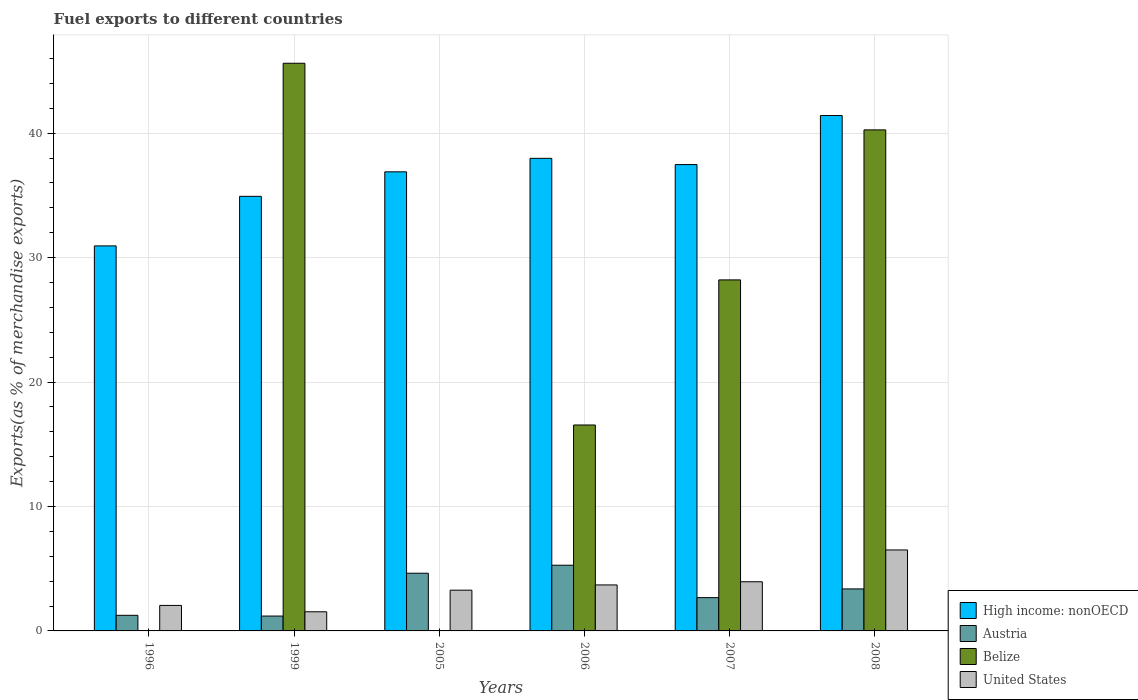How many bars are there on the 4th tick from the left?
Offer a terse response. 4. What is the label of the 3rd group of bars from the left?
Ensure brevity in your answer.  2005. What is the percentage of exports to different countries in Austria in 2007?
Provide a succinct answer. 2.67. Across all years, what is the maximum percentage of exports to different countries in United States?
Offer a very short reply. 6.51. Across all years, what is the minimum percentage of exports to different countries in Belize?
Provide a short and direct response. 9.66092252654547e-5. In which year was the percentage of exports to different countries in Belize minimum?
Ensure brevity in your answer.  2005. What is the total percentage of exports to different countries in Austria in the graph?
Offer a terse response. 18.41. What is the difference between the percentage of exports to different countries in High income: nonOECD in 1996 and that in 2006?
Make the answer very short. -7.04. What is the difference between the percentage of exports to different countries in High income: nonOECD in 2006 and the percentage of exports to different countries in Belize in 1999?
Offer a very short reply. -7.64. What is the average percentage of exports to different countries in Austria per year?
Ensure brevity in your answer.  3.07. In the year 2006, what is the difference between the percentage of exports to different countries in United States and percentage of exports to different countries in High income: nonOECD?
Keep it short and to the point. -34.28. In how many years, is the percentage of exports to different countries in United States greater than 24 %?
Make the answer very short. 0. What is the ratio of the percentage of exports to different countries in Austria in 1999 to that in 2007?
Offer a very short reply. 0.45. Is the percentage of exports to different countries in United States in 2005 less than that in 2006?
Give a very brief answer. Yes. Is the difference between the percentage of exports to different countries in United States in 1999 and 2005 greater than the difference between the percentage of exports to different countries in High income: nonOECD in 1999 and 2005?
Ensure brevity in your answer.  Yes. What is the difference between the highest and the second highest percentage of exports to different countries in United States?
Provide a short and direct response. 2.56. What is the difference between the highest and the lowest percentage of exports to different countries in United States?
Offer a terse response. 4.97. Is the sum of the percentage of exports to different countries in High income: nonOECD in 2005 and 2007 greater than the maximum percentage of exports to different countries in Austria across all years?
Keep it short and to the point. Yes. What does the 1st bar from the left in 2007 represents?
Provide a succinct answer. High income: nonOECD. Is it the case that in every year, the sum of the percentage of exports to different countries in Belize and percentage of exports to different countries in United States is greater than the percentage of exports to different countries in Austria?
Your answer should be compact. No. How many bars are there?
Provide a succinct answer. 24. How many years are there in the graph?
Provide a short and direct response. 6. What is the difference between two consecutive major ticks on the Y-axis?
Offer a very short reply. 10. Does the graph contain any zero values?
Offer a terse response. No. Does the graph contain grids?
Provide a succinct answer. Yes. How many legend labels are there?
Your answer should be compact. 4. What is the title of the graph?
Your answer should be very brief. Fuel exports to different countries. Does "France" appear as one of the legend labels in the graph?
Keep it short and to the point. No. What is the label or title of the Y-axis?
Offer a very short reply. Exports(as % of merchandise exports). What is the Exports(as % of merchandise exports) in High income: nonOECD in 1996?
Offer a very short reply. 30.94. What is the Exports(as % of merchandise exports) in Austria in 1996?
Your answer should be very brief. 1.25. What is the Exports(as % of merchandise exports) in Belize in 1996?
Give a very brief answer. 0. What is the Exports(as % of merchandise exports) of United States in 1996?
Provide a short and direct response. 2.05. What is the Exports(as % of merchandise exports) in High income: nonOECD in 1999?
Your answer should be very brief. 34.92. What is the Exports(as % of merchandise exports) in Austria in 1999?
Your response must be concise. 1.19. What is the Exports(as % of merchandise exports) of Belize in 1999?
Your response must be concise. 45.62. What is the Exports(as % of merchandise exports) of United States in 1999?
Offer a terse response. 1.54. What is the Exports(as % of merchandise exports) of High income: nonOECD in 2005?
Ensure brevity in your answer.  36.89. What is the Exports(as % of merchandise exports) in Austria in 2005?
Your response must be concise. 4.64. What is the Exports(as % of merchandise exports) in Belize in 2005?
Provide a succinct answer. 9.66092252654547e-5. What is the Exports(as % of merchandise exports) of United States in 2005?
Your answer should be compact. 3.27. What is the Exports(as % of merchandise exports) of High income: nonOECD in 2006?
Your answer should be compact. 37.98. What is the Exports(as % of merchandise exports) in Austria in 2006?
Your response must be concise. 5.28. What is the Exports(as % of merchandise exports) in Belize in 2006?
Keep it short and to the point. 16.55. What is the Exports(as % of merchandise exports) in United States in 2006?
Provide a succinct answer. 3.7. What is the Exports(as % of merchandise exports) in High income: nonOECD in 2007?
Your answer should be very brief. 37.48. What is the Exports(as % of merchandise exports) in Austria in 2007?
Your answer should be compact. 2.67. What is the Exports(as % of merchandise exports) of Belize in 2007?
Offer a terse response. 28.21. What is the Exports(as % of merchandise exports) of United States in 2007?
Offer a very short reply. 3.95. What is the Exports(as % of merchandise exports) of High income: nonOECD in 2008?
Offer a very short reply. 41.42. What is the Exports(as % of merchandise exports) of Austria in 2008?
Offer a very short reply. 3.38. What is the Exports(as % of merchandise exports) of Belize in 2008?
Offer a terse response. 40.26. What is the Exports(as % of merchandise exports) in United States in 2008?
Keep it short and to the point. 6.51. Across all years, what is the maximum Exports(as % of merchandise exports) of High income: nonOECD?
Provide a short and direct response. 41.42. Across all years, what is the maximum Exports(as % of merchandise exports) of Austria?
Give a very brief answer. 5.28. Across all years, what is the maximum Exports(as % of merchandise exports) in Belize?
Provide a short and direct response. 45.62. Across all years, what is the maximum Exports(as % of merchandise exports) in United States?
Your answer should be very brief. 6.51. Across all years, what is the minimum Exports(as % of merchandise exports) of High income: nonOECD?
Make the answer very short. 30.94. Across all years, what is the minimum Exports(as % of merchandise exports) in Austria?
Keep it short and to the point. 1.19. Across all years, what is the minimum Exports(as % of merchandise exports) of Belize?
Offer a very short reply. 9.66092252654547e-5. Across all years, what is the minimum Exports(as % of merchandise exports) of United States?
Offer a terse response. 1.54. What is the total Exports(as % of merchandise exports) in High income: nonOECD in the graph?
Ensure brevity in your answer.  219.62. What is the total Exports(as % of merchandise exports) in Austria in the graph?
Your answer should be very brief. 18.41. What is the total Exports(as % of merchandise exports) of Belize in the graph?
Offer a terse response. 130.64. What is the total Exports(as % of merchandise exports) in United States in the graph?
Offer a very short reply. 21.01. What is the difference between the Exports(as % of merchandise exports) of High income: nonOECD in 1996 and that in 1999?
Offer a very short reply. -3.98. What is the difference between the Exports(as % of merchandise exports) in Austria in 1996 and that in 1999?
Your answer should be very brief. 0.06. What is the difference between the Exports(as % of merchandise exports) in Belize in 1996 and that in 1999?
Your answer should be very brief. -45.62. What is the difference between the Exports(as % of merchandise exports) in United States in 1996 and that in 1999?
Provide a succinct answer. 0.51. What is the difference between the Exports(as % of merchandise exports) in High income: nonOECD in 1996 and that in 2005?
Provide a short and direct response. -5.95. What is the difference between the Exports(as % of merchandise exports) in Austria in 1996 and that in 2005?
Provide a short and direct response. -3.38. What is the difference between the Exports(as % of merchandise exports) in United States in 1996 and that in 2005?
Make the answer very short. -1.23. What is the difference between the Exports(as % of merchandise exports) of High income: nonOECD in 1996 and that in 2006?
Keep it short and to the point. -7.04. What is the difference between the Exports(as % of merchandise exports) in Austria in 1996 and that in 2006?
Give a very brief answer. -4.02. What is the difference between the Exports(as % of merchandise exports) in Belize in 1996 and that in 2006?
Offer a very short reply. -16.55. What is the difference between the Exports(as % of merchandise exports) of United States in 1996 and that in 2006?
Give a very brief answer. -1.65. What is the difference between the Exports(as % of merchandise exports) in High income: nonOECD in 1996 and that in 2007?
Offer a very short reply. -6.54. What is the difference between the Exports(as % of merchandise exports) of Austria in 1996 and that in 2007?
Give a very brief answer. -1.42. What is the difference between the Exports(as % of merchandise exports) of Belize in 1996 and that in 2007?
Give a very brief answer. -28.21. What is the difference between the Exports(as % of merchandise exports) of United States in 1996 and that in 2007?
Your answer should be very brief. -1.9. What is the difference between the Exports(as % of merchandise exports) in High income: nonOECD in 1996 and that in 2008?
Provide a succinct answer. -10.48. What is the difference between the Exports(as % of merchandise exports) in Austria in 1996 and that in 2008?
Offer a very short reply. -2.12. What is the difference between the Exports(as % of merchandise exports) of Belize in 1996 and that in 2008?
Make the answer very short. -40.26. What is the difference between the Exports(as % of merchandise exports) of United States in 1996 and that in 2008?
Keep it short and to the point. -4.46. What is the difference between the Exports(as % of merchandise exports) in High income: nonOECD in 1999 and that in 2005?
Provide a short and direct response. -1.97. What is the difference between the Exports(as % of merchandise exports) of Austria in 1999 and that in 2005?
Your answer should be compact. -3.44. What is the difference between the Exports(as % of merchandise exports) of Belize in 1999 and that in 2005?
Your response must be concise. 45.62. What is the difference between the Exports(as % of merchandise exports) in United States in 1999 and that in 2005?
Your answer should be very brief. -1.74. What is the difference between the Exports(as % of merchandise exports) in High income: nonOECD in 1999 and that in 2006?
Ensure brevity in your answer.  -3.05. What is the difference between the Exports(as % of merchandise exports) in Austria in 1999 and that in 2006?
Keep it short and to the point. -4.08. What is the difference between the Exports(as % of merchandise exports) of Belize in 1999 and that in 2006?
Your answer should be very brief. 29.07. What is the difference between the Exports(as % of merchandise exports) of United States in 1999 and that in 2006?
Your response must be concise. -2.16. What is the difference between the Exports(as % of merchandise exports) in High income: nonOECD in 1999 and that in 2007?
Give a very brief answer. -2.55. What is the difference between the Exports(as % of merchandise exports) in Austria in 1999 and that in 2007?
Give a very brief answer. -1.48. What is the difference between the Exports(as % of merchandise exports) of Belize in 1999 and that in 2007?
Make the answer very short. 17.41. What is the difference between the Exports(as % of merchandise exports) in United States in 1999 and that in 2007?
Give a very brief answer. -2.41. What is the difference between the Exports(as % of merchandise exports) in High income: nonOECD in 1999 and that in 2008?
Offer a terse response. -6.49. What is the difference between the Exports(as % of merchandise exports) in Austria in 1999 and that in 2008?
Provide a short and direct response. -2.18. What is the difference between the Exports(as % of merchandise exports) of Belize in 1999 and that in 2008?
Provide a succinct answer. 5.35. What is the difference between the Exports(as % of merchandise exports) in United States in 1999 and that in 2008?
Give a very brief answer. -4.97. What is the difference between the Exports(as % of merchandise exports) in High income: nonOECD in 2005 and that in 2006?
Provide a short and direct response. -1.08. What is the difference between the Exports(as % of merchandise exports) of Austria in 2005 and that in 2006?
Your response must be concise. -0.64. What is the difference between the Exports(as % of merchandise exports) of Belize in 2005 and that in 2006?
Offer a terse response. -16.55. What is the difference between the Exports(as % of merchandise exports) of United States in 2005 and that in 2006?
Your answer should be very brief. -0.42. What is the difference between the Exports(as % of merchandise exports) in High income: nonOECD in 2005 and that in 2007?
Keep it short and to the point. -0.58. What is the difference between the Exports(as % of merchandise exports) in Austria in 2005 and that in 2007?
Ensure brevity in your answer.  1.96. What is the difference between the Exports(as % of merchandise exports) of Belize in 2005 and that in 2007?
Offer a very short reply. -28.21. What is the difference between the Exports(as % of merchandise exports) in United States in 2005 and that in 2007?
Your answer should be compact. -0.68. What is the difference between the Exports(as % of merchandise exports) of High income: nonOECD in 2005 and that in 2008?
Ensure brevity in your answer.  -4.52. What is the difference between the Exports(as % of merchandise exports) in Austria in 2005 and that in 2008?
Your response must be concise. 1.26. What is the difference between the Exports(as % of merchandise exports) in Belize in 2005 and that in 2008?
Your answer should be very brief. -40.26. What is the difference between the Exports(as % of merchandise exports) in United States in 2005 and that in 2008?
Offer a terse response. -3.23. What is the difference between the Exports(as % of merchandise exports) of High income: nonOECD in 2006 and that in 2007?
Provide a short and direct response. 0.5. What is the difference between the Exports(as % of merchandise exports) of Austria in 2006 and that in 2007?
Provide a short and direct response. 2.6. What is the difference between the Exports(as % of merchandise exports) of Belize in 2006 and that in 2007?
Keep it short and to the point. -11.66. What is the difference between the Exports(as % of merchandise exports) of United States in 2006 and that in 2007?
Offer a very short reply. -0.26. What is the difference between the Exports(as % of merchandise exports) in High income: nonOECD in 2006 and that in 2008?
Offer a terse response. -3.44. What is the difference between the Exports(as % of merchandise exports) in Austria in 2006 and that in 2008?
Provide a short and direct response. 1.9. What is the difference between the Exports(as % of merchandise exports) of Belize in 2006 and that in 2008?
Offer a very short reply. -23.71. What is the difference between the Exports(as % of merchandise exports) of United States in 2006 and that in 2008?
Offer a very short reply. -2.81. What is the difference between the Exports(as % of merchandise exports) of High income: nonOECD in 2007 and that in 2008?
Your answer should be compact. -3.94. What is the difference between the Exports(as % of merchandise exports) in Austria in 2007 and that in 2008?
Give a very brief answer. -0.7. What is the difference between the Exports(as % of merchandise exports) of Belize in 2007 and that in 2008?
Keep it short and to the point. -12.05. What is the difference between the Exports(as % of merchandise exports) of United States in 2007 and that in 2008?
Your answer should be compact. -2.56. What is the difference between the Exports(as % of merchandise exports) in High income: nonOECD in 1996 and the Exports(as % of merchandise exports) in Austria in 1999?
Offer a terse response. 29.75. What is the difference between the Exports(as % of merchandise exports) of High income: nonOECD in 1996 and the Exports(as % of merchandise exports) of Belize in 1999?
Your answer should be very brief. -14.68. What is the difference between the Exports(as % of merchandise exports) of High income: nonOECD in 1996 and the Exports(as % of merchandise exports) of United States in 1999?
Keep it short and to the point. 29.4. What is the difference between the Exports(as % of merchandise exports) in Austria in 1996 and the Exports(as % of merchandise exports) in Belize in 1999?
Provide a succinct answer. -44.36. What is the difference between the Exports(as % of merchandise exports) in Austria in 1996 and the Exports(as % of merchandise exports) in United States in 1999?
Make the answer very short. -0.28. What is the difference between the Exports(as % of merchandise exports) of Belize in 1996 and the Exports(as % of merchandise exports) of United States in 1999?
Give a very brief answer. -1.54. What is the difference between the Exports(as % of merchandise exports) in High income: nonOECD in 1996 and the Exports(as % of merchandise exports) in Austria in 2005?
Offer a terse response. 26.3. What is the difference between the Exports(as % of merchandise exports) in High income: nonOECD in 1996 and the Exports(as % of merchandise exports) in Belize in 2005?
Offer a very short reply. 30.94. What is the difference between the Exports(as % of merchandise exports) in High income: nonOECD in 1996 and the Exports(as % of merchandise exports) in United States in 2005?
Provide a succinct answer. 27.67. What is the difference between the Exports(as % of merchandise exports) in Austria in 1996 and the Exports(as % of merchandise exports) in Belize in 2005?
Offer a very short reply. 1.25. What is the difference between the Exports(as % of merchandise exports) in Austria in 1996 and the Exports(as % of merchandise exports) in United States in 2005?
Provide a short and direct response. -2.02. What is the difference between the Exports(as % of merchandise exports) of Belize in 1996 and the Exports(as % of merchandise exports) of United States in 2005?
Your response must be concise. -3.27. What is the difference between the Exports(as % of merchandise exports) in High income: nonOECD in 1996 and the Exports(as % of merchandise exports) in Austria in 2006?
Give a very brief answer. 25.66. What is the difference between the Exports(as % of merchandise exports) of High income: nonOECD in 1996 and the Exports(as % of merchandise exports) of Belize in 2006?
Give a very brief answer. 14.39. What is the difference between the Exports(as % of merchandise exports) in High income: nonOECD in 1996 and the Exports(as % of merchandise exports) in United States in 2006?
Provide a short and direct response. 27.24. What is the difference between the Exports(as % of merchandise exports) in Austria in 1996 and the Exports(as % of merchandise exports) in Belize in 2006?
Provide a succinct answer. -15.29. What is the difference between the Exports(as % of merchandise exports) of Austria in 1996 and the Exports(as % of merchandise exports) of United States in 2006?
Keep it short and to the point. -2.44. What is the difference between the Exports(as % of merchandise exports) in Belize in 1996 and the Exports(as % of merchandise exports) in United States in 2006?
Ensure brevity in your answer.  -3.7. What is the difference between the Exports(as % of merchandise exports) of High income: nonOECD in 1996 and the Exports(as % of merchandise exports) of Austria in 2007?
Make the answer very short. 28.27. What is the difference between the Exports(as % of merchandise exports) of High income: nonOECD in 1996 and the Exports(as % of merchandise exports) of Belize in 2007?
Offer a terse response. 2.73. What is the difference between the Exports(as % of merchandise exports) in High income: nonOECD in 1996 and the Exports(as % of merchandise exports) in United States in 2007?
Ensure brevity in your answer.  26.99. What is the difference between the Exports(as % of merchandise exports) of Austria in 1996 and the Exports(as % of merchandise exports) of Belize in 2007?
Offer a very short reply. -26.95. What is the difference between the Exports(as % of merchandise exports) of Austria in 1996 and the Exports(as % of merchandise exports) of United States in 2007?
Ensure brevity in your answer.  -2.7. What is the difference between the Exports(as % of merchandise exports) in Belize in 1996 and the Exports(as % of merchandise exports) in United States in 2007?
Provide a succinct answer. -3.95. What is the difference between the Exports(as % of merchandise exports) in High income: nonOECD in 1996 and the Exports(as % of merchandise exports) in Austria in 2008?
Keep it short and to the point. 27.56. What is the difference between the Exports(as % of merchandise exports) in High income: nonOECD in 1996 and the Exports(as % of merchandise exports) in Belize in 2008?
Give a very brief answer. -9.32. What is the difference between the Exports(as % of merchandise exports) of High income: nonOECD in 1996 and the Exports(as % of merchandise exports) of United States in 2008?
Provide a short and direct response. 24.43. What is the difference between the Exports(as % of merchandise exports) of Austria in 1996 and the Exports(as % of merchandise exports) of Belize in 2008?
Provide a short and direct response. -39.01. What is the difference between the Exports(as % of merchandise exports) of Austria in 1996 and the Exports(as % of merchandise exports) of United States in 2008?
Keep it short and to the point. -5.25. What is the difference between the Exports(as % of merchandise exports) of Belize in 1996 and the Exports(as % of merchandise exports) of United States in 2008?
Offer a terse response. -6.51. What is the difference between the Exports(as % of merchandise exports) of High income: nonOECD in 1999 and the Exports(as % of merchandise exports) of Austria in 2005?
Ensure brevity in your answer.  30.29. What is the difference between the Exports(as % of merchandise exports) of High income: nonOECD in 1999 and the Exports(as % of merchandise exports) of Belize in 2005?
Your response must be concise. 34.92. What is the difference between the Exports(as % of merchandise exports) in High income: nonOECD in 1999 and the Exports(as % of merchandise exports) in United States in 2005?
Provide a succinct answer. 31.65. What is the difference between the Exports(as % of merchandise exports) in Austria in 1999 and the Exports(as % of merchandise exports) in Belize in 2005?
Ensure brevity in your answer.  1.19. What is the difference between the Exports(as % of merchandise exports) of Austria in 1999 and the Exports(as % of merchandise exports) of United States in 2005?
Your answer should be very brief. -2.08. What is the difference between the Exports(as % of merchandise exports) in Belize in 1999 and the Exports(as % of merchandise exports) in United States in 2005?
Provide a succinct answer. 42.34. What is the difference between the Exports(as % of merchandise exports) of High income: nonOECD in 1999 and the Exports(as % of merchandise exports) of Austria in 2006?
Make the answer very short. 29.64. What is the difference between the Exports(as % of merchandise exports) of High income: nonOECD in 1999 and the Exports(as % of merchandise exports) of Belize in 2006?
Give a very brief answer. 18.38. What is the difference between the Exports(as % of merchandise exports) of High income: nonOECD in 1999 and the Exports(as % of merchandise exports) of United States in 2006?
Give a very brief answer. 31.23. What is the difference between the Exports(as % of merchandise exports) in Austria in 1999 and the Exports(as % of merchandise exports) in Belize in 2006?
Ensure brevity in your answer.  -15.35. What is the difference between the Exports(as % of merchandise exports) of Austria in 1999 and the Exports(as % of merchandise exports) of United States in 2006?
Your response must be concise. -2.5. What is the difference between the Exports(as % of merchandise exports) in Belize in 1999 and the Exports(as % of merchandise exports) in United States in 2006?
Make the answer very short. 41.92. What is the difference between the Exports(as % of merchandise exports) of High income: nonOECD in 1999 and the Exports(as % of merchandise exports) of Austria in 2007?
Offer a terse response. 32.25. What is the difference between the Exports(as % of merchandise exports) of High income: nonOECD in 1999 and the Exports(as % of merchandise exports) of Belize in 2007?
Make the answer very short. 6.72. What is the difference between the Exports(as % of merchandise exports) of High income: nonOECD in 1999 and the Exports(as % of merchandise exports) of United States in 2007?
Your answer should be very brief. 30.97. What is the difference between the Exports(as % of merchandise exports) in Austria in 1999 and the Exports(as % of merchandise exports) in Belize in 2007?
Offer a terse response. -27.01. What is the difference between the Exports(as % of merchandise exports) of Austria in 1999 and the Exports(as % of merchandise exports) of United States in 2007?
Your answer should be very brief. -2.76. What is the difference between the Exports(as % of merchandise exports) in Belize in 1999 and the Exports(as % of merchandise exports) in United States in 2007?
Your answer should be compact. 41.67. What is the difference between the Exports(as % of merchandise exports) in High income: nonOECD in 1999 and the Exports(as % of merchandise exports) in Austria in 2008?
Offer a very short reply. 31.55. What is the difference between the Exports(as % of merchandise exports) of High income: nonOECD in 1999 and the Exports(as % of merchandise exports) of Belize in 2008?
Ensure brevity in your answer.  -5.34. What is the difference between the Exports(as % of merchandise exports) in High income: nonOECD in 1999 and the Exports(as % of merchandise exports) in United States in 2008?
Your response must be concise. 28.42. What is the difference between the Exports(as % of merchandise exports) in Austria in 1999 and the Exports(as % of merchandise exports) in Belize in 2008?
Offer a very short reply. -39.07. What is the difference between the Exports(as % of merchandise exports) in Austria in 1999 and the Exports(as % of merchandise exports) in United States in 2008?
Your response must be concise. -5.31. What is the difference between the Exports(as % of merchandise exports) in Belize in 1999 and the Exports(as % of merchandise exports) in United States in 2008?
Offer a very short reply. 39.11. What is the difference between the Exports(as % of merchandise exports) in High income: nonOECD in 2005 and the Exports(as % of merchandise exports) in Austria in 2006?
Provide a short and direct response. 31.61. What is the difference between the Exports(as % of merchandise exports) in High income: nonOECD in 2005 and the Exports(as % of merchandise exports) in Belize in 2006?
Offer a terse response. 20.34. What is the difference between the Exports(as % of merchandise exports) of High income: nonOECD in 2005 and the Exports(as % of merchandise exports) of United States in 2006?
Give a very brief answer. 33.2. What is the difference between the Exports(as % of merchandise exports) in Austria in 2005 and the Exports(as % of merchandise exports) in Belize in 2006?
Provide a succinct answer. -11.91. What is the difference between the Exports(as % of merchandise exports) in Austria in 2005 and the Exports(as % of merchandise exports) in United States in 2006?
Ensure brevity in your answer.  0.94. What is the difference between the Exports(as % of merchandise exports) of Belize in 2005 and the Exports(as % of merchandise exports) of United States in 2006?
Keep it short and to the point. -3.7. What is the difference between the Exports(as % of merchandise exports) in High income: nonOECD in 2005 and the Exports(as % of merchandise exports) in Austria in 2007?
Give a very brief answer. 34.22. What is the difference between the Exports(as % of merchandise exports) in High income: nonOECD in 2005 and the Exports(as % of merchandise exports) in Belize in 2007?
Make the answer very short. 8.68. What is the difference between the Exports(as % of merchandise exports) of High income: nonOECD in 2005 and the Exports(as % of merchandise exports) of United States in 2007?
Provide a short and direct response. 32.94. What is the difference between the Exports(as % of merchandise exports) in Austria in 2005 and the Exports(as % of merchandise exports) in Belize in 2007?
Your answer should be compact. -23.57. What is the difference between the Exports(as % of merchandise exports) of Austria in 2005 and the Exports(as % of merchandise exports) of United States in 2007?
Ensure brevity in your answer.  0.69. What is the difference between the Exports(as % of merchandise exports) of Belize in 2005 and the Exports(as % of merchandise exports) of United States in 2007?
Provide a succinct answer. -3.95. What is the difference between the Exports(as % of merchandise exports) of High income: nonOECD in 2005 and the Exports(as % of merchandise exports) of Austria in 2008?
Give a very brief answer. 33.52. What is the difference between the Exports(as % of merchandise exports) of High income: nonOECD in 2005 and the Exports(as % of merchandise exports) of Belize in 2008?
Give a very brief answer. -3.37. What is the difference between the Exports(as % of merchandise exports) in High income: nonOECD in 2005 and the Exports(as % of merchandise exports) in United States in 2008?
Offer a very short reply. 30.39. What is the difference between the Exports(as % of merchandise exports) of Austria in 2005 and the Exports(as % of merchandise exports) of Belize in 2008?
Keep it short and to the point. -35.63. What is the difference between the Exports(as % of merchandise exports) in Austria in 2005 and the Exports(as % of merchandise exports) in United States in 2008?
Ensure brevity in your answer.  -1.87. What is the difference between the Exports(as % of merchandise exports) in Belize in 2005 and the Exports(as % of merchandise exports) in United States in 2008?
Keep it short and to the point. -6.51. What is the difference between the Exports(as % of merchandise exports) of High income: nonOECD in 2006 and the Exports(as % of merchandise exports) of Austria in 2007?
Your answer should be very brief. 35.3. What is the difference between the Exports(as % of merchandise exports) of High income: nonOECD in 2006 and the Exports(as % of merchandise exports) of Belize in 2007?
Offer a terse response. 9.77. What is the difference between the Exports(as % of merchandise exports) in High income: nonOECD in 2006 and the Exports(as % of merchandise exports) in United States in 2007?
Ensure brevity in your answer.  34.02. What is the difference between the Exports(as % of merchandise exports) in Austria in 2006 and the Exports(as % of merchandise exports) in Belize in 2007?
Your answer should be compact. -22.93. What is the difference between the Exports(as % of merchandise exports) in Austria in 2006 and the Exports(as % of merchandise exports) in United States in 2007?
Your answer should be very brief. 1.33. What is the difference between the Exports(as % of merchandise exports) in Belize in 2006 and the Exports(as % of merchandise exports) in United States in 2007?
Provide a succinct answer. 12.6. What is the difference between the Exports(as % of merchandise exports) in High income: nonOECD in 2006 and the Exports(as % of merchandise exports) in Austria in 2008?
Give a very brief answer. 34.6. What is the difference between the Exports(as % of merchandise exports) in High income: nonOECD in 2006 and the Exports(as % of merchandise exports) in Belize in 2008?
Keep it short and to the point. -2.29. What is the difference between the Exports(as % of merchandise exports) in High income: nonOECD in 2006 and the Exports(as % of merchandise exports) in United States in 2008?
Your answer should be compact. 31.47. What is the difference between the Exports(as % of merchandise exports) in Austria in 2006 and the Exports(as % of merchandise exports) in Belize in 2008?
Your response must be concise. -34.98. What is the difference between the Exports(as % of merchandise exports) in Austria in 2006 and the Exports(as % of merchandise exports) in United States in 2008?
Keep it short and to the point. -1.23. What is the difference between the Exports(as % of merchandise exports) of Belize in 2006 and the Exports(as % of merchandise exports) of United States in 2008?
Keep it short and to the point. 10.04. What is the difference between the Exports(as % of merchandise exports) in High income: nonOECD in 2007 and the Exports(as % of merchandise exports) in Austria in 2008?
Ensure brevity in your answer.  34.1. What is the difference between the Exports(as % of merchandise exports) in High income: nonOECD in 2007 and the Exports(as % of merchandise exports) in Belize in 2008?
Provide a short and direct response. -2.79. What is the difference between the Exports(as % of merchandise exports) in High income: nonOECD in 2007 and the Exports(as % of merchandise exports) in United States in 2008?
Provide a succinct answer. 30.97. What is the difference between the Exports(as % of merchandise exports) in Austria in 2007 and the Exports(as % of merchandise exports) in Belize in 2008?
Offer a very short reply. -37.59. What is the difference between the Exports(as % of merchandise exports) of Austria in 2007 and the Exports(as % of merchandise exports) of United States in 2008?
Ensure brevity in your answer.  -3.83. What is the difference between the Exports(as % of merchandise exports) in Belize in 2007 and the Exports(as % of merchandise exports) in United States in 2008?
Your answer should be very brief. 21.7. What is the average Exports(as % of merchandise exports) in High income: nonOECD per year?
Your answer should be very brief. 36.6. What is the average Exports(as % of merchandise exports) of Austria per year?
Your response must be concise. 3.07. What is the average Exports(as % of merchandise exports) of Belize per year?
Provide a short and direct response. 21.77. What is the average Exports(as % of merchandise exports) in United States per year?
Offer a terse response. 3.5. In the year 1996, what is the difference between the Exports(as % of merchandise exports) in High income: nonOECD and Exports(as % of merchandise exports) in Austria?
Your answer should be very brief. 29.69. In the year 1996, what is the difference between the Exports(as % of merchandise exports) of High income: nonOECD and Exports(as % of merchandise exports) of Belize?
Offer a terse response. 30.94. In the year 1996, what is the difference between the Exports(as % of merchandise exports) in High income: nonOECD and Exports(as % of merchandise exports) in United States?
Keep it short and to the point. 28.89. In the year 1996, what is the difference between the Exports(as % of merchandise exports) in Austria and Exports(as % of merchandise exports) in Belize?
Offer a very short reply. 1.25. In the year 1996, what is the difference between the Exports(as % of merchandise exports) in Austria and Exports(as % of merchandise exports) in United States?
Your answer should be very brief. -0.79. In the year 1996, what is the difference between the Exports(as % of merchandise exports) in Belize and Exports(as % of merchandise exports) in United States?
Make the answer very short. -2.05. In the year 1999, what is the difference between the Exports(as % of merchandise exports) in High income: nonOECD and Exports(as % of merchandise exports) in Austria?
Provide a short and direct response. 33.73. In the year 1999, what is the difference between the Exports(as % of merchandise exports) of High income: nonOECD and Exports(as % of merchandise exports) of Belize?
Your response must be concise. -10.69. In the year 1999, what is the difference between the Exports(as % of merchandise exports) in High income: nonOECD and Exports(as % of merchandise exports) in United States?
Offer a terse response. 33.38. In the year 1999, what is the difference between the Exports(as % of merchandise exports) in Austria and Exports(as % of merchandise exports) in Belize?
Offer a terse response. -44.42. In the year 1999, what is the difference between the Exports(as % of merchandise exports) of Austria and Exports(as % of merchandise exports) of United States?
Keep it short and to the point. -0.34. In the year 1999, what is the difference between the Exports(as % of merchandise exports) of Belize and Exports(as % of merchandise exports) of United States?
Offer a terse response. 44.08. In the year 2005, what is the difference between the Exports(as % of merchandise exports) of High income: nonOECD and Exports(as % of merchandise exports) of Austria?
Offer a terse response. 32.26. In the year 2005, what is the difference between the Exports(as % of merchandise exports) in High income: nonOECD and Exports(as % of merchandise exports) in Belize?
Your response must be concise. 36.89. In the year 2005, what is the difference between the Exports(as % of merchandise exports) of High income: nonOECD and Exports(as % of merchandise exports) of United States?
Provide a short and direct response. 33.62. In the year 2005, what is the difference between the Exports(as % of merchandise exports) of Austria and Exports(as % of merchandise exports) of Belize?
Provide a succinct answer. 4.64. In the year 2005, what is the difference between the Exports(as % of merchandise exports) in Austria and Exports(as % of merchandise exports) in United States?
Offer a terse response. 1.36. In the year 2005, what is the difference between the Exports(as % of merchandise exports) in Belize and Exports(as % of merchandise exports) in United States?
Provide a succinct answer. -3.27. In the year 2006, what is the difference between the Exports(as % of merchandise exports) in High income: nonOECD and Exports(as % of merchandise exports) in Austria?
Provide a succinct answer. 32.7. In the year 2006, what is the difference between the Exports(as % of merchandise exports) of High income: nonOECD and Exports(as % of merchandise exports) of Belize?
Your answer should be compact. 21.43. In the year 2006, what is the difference between the Exports(as % of merchandise exports) in High income: nonOECD and Exports(as % of merchandise exports) in United States?
Ensure brevity in your answer.  34.28. In the year 2006, what is the difference between the Exports(as % of merchandise exports) in Austria and Exports(as % of merchandise exports) in Belize?
Your response must be concise. -11.27. In the year 2006, what is the difference between the Exports(as % of merchandise exports) of Austria and Exports(as % of merchandise exports) of United States?
Give a very brief answer. 1.58. In the year 2006, what is the difference between the Exports(as % of merchandise exports) of Belize and Exports(as % of merchandise exports) of United States?
Provide a short and direct response. 12.85. In the year 2007, what is the difference between the Exports(as % of merchandise exports) in High income: nonOECD and Exports(as % of merchandise exports) in Austria?
Make the answer very short. 34.8. In the year 2007, what is the difference between the Exports(as % of merchandise exports) in High income: nonOECD and Exports(as % of merchandise exports) in Belize?
Offer a very short reply. 9.27. In the year 2007, what is the difference between the Exports(as % of merchandise exports) in High income: nonOECD and Exports(as % of merchandise exports) in United States?
Provide a short and direct response. 33.52. In the year 2007, what is the difference between the Exports(as % of merchandise exports) in Austria and Exports(as % of merchandise exports) in Belize?
Give a very brief answer. -25.53. In the year 2007, what is the difference between the Exports(as % of merchandise exports) in Austria and Exports(as % of merchandise exports) in United States?
Provide a short and direct response. -1.28. In the year 2007, what is the difference between the Exports(as % of merchandise exports) of Belize and Exports(as % of merchandise exports) of United States?
Provide a short and direct response. 24.26. In the year 2008, what is the difference between the Exports(as % of merchandise exports) of High income: nonOECD and Exports(as % of merchandise exports) of Austria?
Provide a short and direct response. 38.04. In the year 2008, what is the difference between the Exports(as % of merchandise exports) in High income: nonOECD and Exports(as % of merchandise exports) in Belize?
Ensure brevity in your answer.  1.15. In the year 2008, what is the difference between the Exports(as % of merchandise exports) in High income: nonOECD and Exports(as % of merchandise exports) in United States?
Your answer should be very brief. 34.91. In the year 2008, what is the difference between the Exports(as % of merchandise exports) of Austria and Exports(as % of merchandise exports) of Belize?
Your response must be concise. -36.89. In the year 2008, what is the difference between the Exports(as % of merchandise exports) in Austria and Exports(as % of merchandise exports) in United States?
Your response must be concise. -3.13. In the year 2008, what is the difference between the Exports(as % of merchandise exports) in Belize and Exports(as % of merchandise exports) in United States?
Offer a terse response. 33.76. What is the ratio of the Exports(as % of merchandise exports) of High income: nonOECD in 1996 to that in 1999?
Your response must be concise. 0.89. What is the ratio of the Exports(as % of merchandise exports) in United States in 1996 to that in 1999?
Give a very brief answer. 1.33. What is the ratio of the Exports(as % of merchandise exports) in High income: nonOECD in 1996 to that in 2005?
Your answer should be compact. 0.84. What is the ratio of the Exports(as % of merchandise exports) of Austria in 1996 to that in 2005?
Provide a succinct answer. 0.27. What is the ratio of the Exports(as % of merchandise exports) in Belize in 1996 to that in 2005?
Ensure brevity in your answer.  3.59. What is the ratio of the Exports(as % of merchandise exports) of United States in 1996 to that in 2005?
Ensure brevity in your answer.  0.63. What is the ratio of the Exports(as % of merchandise exports) in High income: nonOECD in 1996 to that in 2006?
Ensure brevity in your answer.  0.81. What is the ratio of the Exports(as % of merchandise exports) of Austria in 1996 to that in 2006?
Your answer should be very brief. 0.24. What is the ratio of the Exports(as % of merchandise exports) of United States in 1996 to that in 2006?
Offer a terse response. 0.55. What is the ratio of the Exports(as % of merchandise exports) of High income: nonOECD in 1996 to that in 2007?
Provide a short and direct response. 0.83. What is the ratio of the Exports(as % of merchandise exports) in Austria in 1996 to that in 2007?
Ensure brevity in your answer.  0.47. What is the ratio of the Exports(as % of merchandise exports) of United States in 1996 to that in 2007?
Offer a terse response. 0.52. What is the ratio of the Exports(as % of merchandise exports) in High income: nonOECD in 1996 to that in 2008?
Provide a short and direct response. 0.75. What is the ratio of the Exports(as % of merchandise exports) in Austria in 1996 to that in 2008?
Provide a short and direct response. 0.37. What is the ratio of the Exports(as % of merchandise exports) in United States in 1996 to that in 2008?
Your answer should be very brief. 0.31. What is the ratio of the Exports(as % of merchandise exports) in High income: nonOECD in 1999 to that in 2005?
Make the answer very short. 0.95. What is the ratio of the Exports(as % of merchandise exports) in Austria in 1999 to that in 2005?
Offer a very short reply. 0.26. What is the ratio of the Exports(as % of merchandise exports) of Belize in 1999 to that in 2005?
Offer a very short reply. 4.72e+05. What is the ratio of the Exports(as % of merchandise exports) in United States in 1999 to that in 2005?
Your answer should be very brief. 0.47. What is the ratio of the Exports(as % of merchandise exports) in High income: nonOECD in 1999 to that in 2006?
Keep it short and to the point. 0.92. What is the ratio of the Exports(as % of merchandise exports) in Austria in 1999 to that in 2006?
Offer a terse response. 0.23. What is the ratio of the Exports(as % of merchandise exports) of Belize in 1999 to that in 2006?
Your response must be concise. 2.76. What is the ratio of the Exports(as % of merchandise exports) of United States in 1999 to that in 2006?
Offer a terse response. 0.42. What is the ratio of the Exports(as % of merchandise exports) in High income: nonOECD in 1999 to that in 2007?
Offer a very short reply. 0.93. What is the ratio of the Exports(as % of merchandise exports) in Austria in 1999 to that in 2007?
Ensure brevity in your answer.  0.45. What is the ratio of the Exports(as % of merchandise exports) in Belize in 1999 to that in 2007?
Make the answer very short. 1.62. What is the ratio of the Exports(as % of merchandise exports) of United States in 1999 to that in 2007?
Provide a short and direct response. 0.39. What is the ratio of the Exports(as % of merchandise exports) of High income: nonOECD in 1999 to that in 2008?
Give a very brief answer. 0.84. What is the ratio of the Exports(as % of merchandise exports) in Austria in 1999 to that in 2008?
Your answer should be very brief. 0.35. What is the ratio of the Exports(as % of merchandise exports) in Belize in 1999 to that in 2008?
Make the answer very short. 1.13. What is the ratio of the Exports(as % of merchandise exports) in United States in 1999 to that in 2008?
Give a very brief answer. 0.24. What is the ratio of the Exports(as % of merchandise exports) of High income: nonOECD in 2005 to that in 2006?
Provide a short and direct response. 0.97. What is the ratio of the Exports(as % of merchandise exports) in Austria in 2005 to that in 2006?
Provide a short and direct response. 0.88. What is the ratio of the Exports(as % of merchandise exports) in United States in 2005 to that in 2006?
Keep it short and to the point. 0.89. What is the ratio of the Exports(as % of merchandise exports) in High income: nonOECD in 2005 to that in 2007?
Provide a succinct answer. 0.98. What is the ratio of the Exports(as % of merchandise exports) in Austria in 2005 to that in 2007?
Provide a succinct answer. 1.73. What is the ratio of the Exports(as % of merchandise exports) of Belize in 2005 to that in 2007?
Give a very brief answer. 0. What is the ratio of the Exports(as % of merchandise exports) of United States in 2005 to that in 2007?
Ensure brevity in your answer.  0.83. What is the ratio of the Exports(as % of merchandise exports) in High income: nonOECD in 2005 to that in 2008?
Your response must be concise. 0.89. What is the ratio of the Exports(as % of merchandise exports) in Austria in 2005 to that in 2008?
Keep it short and to the point. 1.37. What is the ratio of the Exports(as % of merchandise exports) of United States in 2005 to that in 2008?
Your answer should be very brief. 0.5. What is the ratio of the Exports(as % of merchandise exports) in High income: nonOECD in 2006 to that in 2007?
Ensure brevity in your answer.  1.01. What is the ratio of the Exports(as % of merchandise exports) of Austria in 2006 to that in 2007?
Keep it short and to the point. 1.97. What is the ratio of the Exports(as % of merchandise exports) in Belize in 2006 to that in 2007?
Your response must be concise. 0.59. What is the ratio of the Exports(as % of merchandise exports) of United States in 2006 to that in 2007?
Provide a succinct answer. 0.94. What is the ratio of the Exports(as % of merchandise exports) in High income: nonOECD in 2006 to that in 2008?
Your answer should be compact. 0.92. What is the ratio of the Exports(as % of merchandise exports) of Austria in 2006 to that in 2008?
Your answer should be compact. 1.56. What is the ratio of the Exports(as % of merchandise exports) in Belize in 2006 to that in 2008?
Your answer should be compact. 0.41. What is the ratio of the Exports(as % of merchandise exports) of United States in 2006 to that in 2008?
Make the answer very short. 0.57. What is the ratio of the Exports(as % of merchandise exports) in High income: nonOECD in 2007 to that in 2008?
Make the answer very short. 0.9. What is the ratio of the Exports(as % of merchandise exports) in Austria in 2007 to that in 2008?
Make the answer very short. 0.79. What is the ratio of the Exports(as % of merchandise exports) in Belize in 2007 to that in 2008?
Offer a terse response. 0.7. What is the ratio of the Exports(as % of merchandise exports) in United States in 2007 to that in 2008?
Your answer should be very brief. 0.61. What is the difference between the highest and the second highest Exports(as % of merchandise exports) of High income: nonOECD?
Give a very brief answer. 3.44. What is the difference between the highest and the second highest Exports(as % of merchandise exports) in Austria?
Provide a succinct answer. 0.64. What is the difference between the highest and the second highest Exports(as % of merchandise exports) of Belize?
Keep it short and to the point. 5.35. What is the difference between the highest and the second highest Exports(as % of merchandise exports) of United States?
Make the answer very short. 2.56. What is the difference between the highest and the lowest Exports(as % of merchandise exports) in High income: nonOECD?
Ensure brevity in your answer.  10.48. What is the difference between the highest and the lowest Exports(as % of merchandise exports) of Austria?
Ensure brevity in your answer.  4.08. What is the difference between the highest and the lowest Exports(as % of merchandise exports) in Belize?
Your answer should be compact. 45.62. What is the difference between the highest and the lowest Exports(as % of merchandise exports) in United States?
Keep it short and to the point. 4.97. 